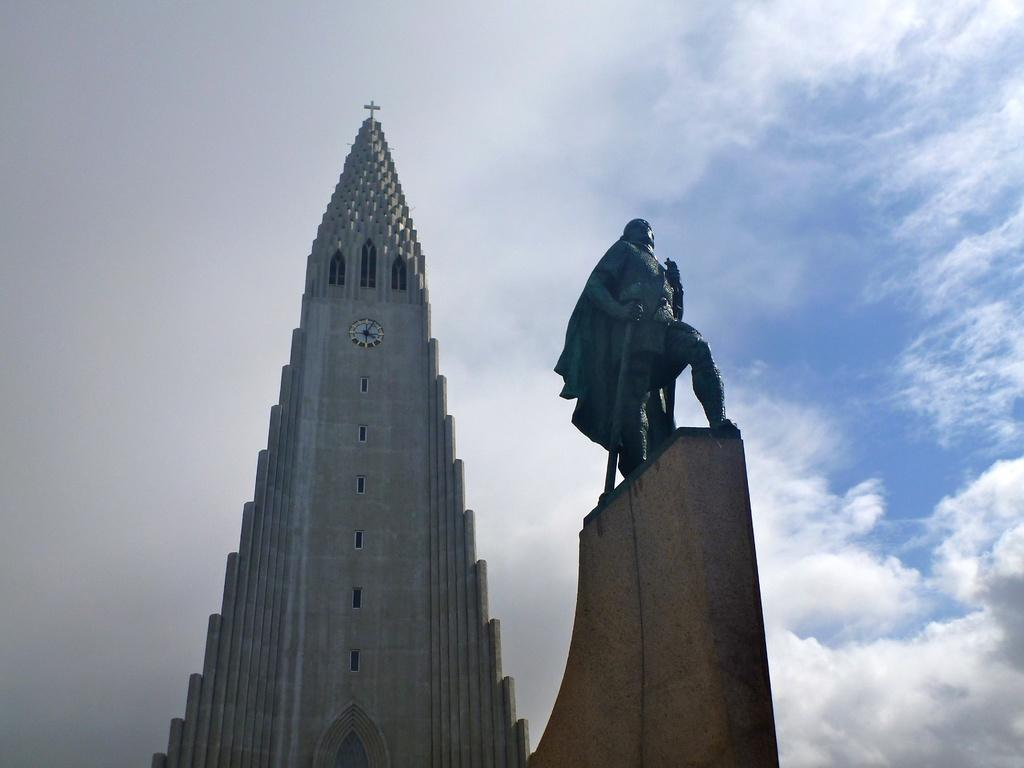What type of building is in the image? There is a church in the image. How would you describe the size of the church? The church is described as gigantic. What is on top of the church? There is a clock on top of the church. Where is the clock positioned on the church? The clock is positioned between two parts of the church. What can be seen on the right side of the church? There is a tall sculpture of a warrior on the right side of the church. What type of coach can be seen in the image? There is no coach present in the image; it features a church with a clock, a sculpture, and a description of its size. What time of day is it in the image, based on the presence of the afternoon sun? The provided facts do not mention the time of day or the presence of the sun, so it cannot be determined from the image. 